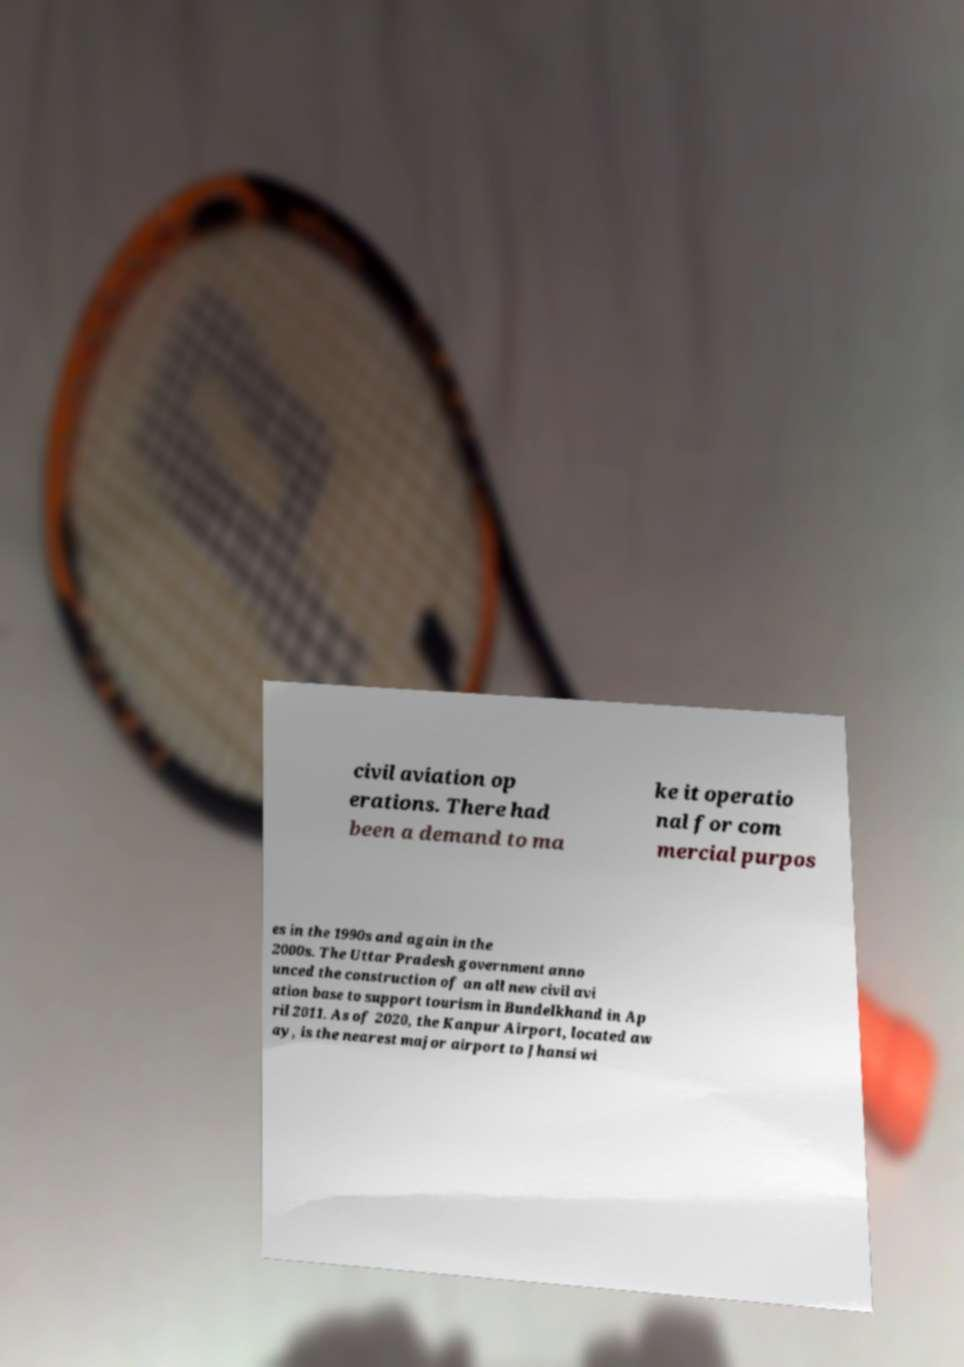I need the written content from this picture converted into text. Can you do that? civil aviation op erations. There had been a demand to ma ke it operatio nal for com mercial purpos es in the 1990s and again in the 2000s. The Uttar Pradesh government anno unced the construction of an all new civil avi ation base to support tourism in Bundelkhand in Ap ril 2011. As of 2020, the Kanpur Airport, located aw ay, is the nearest major airport to Jhansi wi 